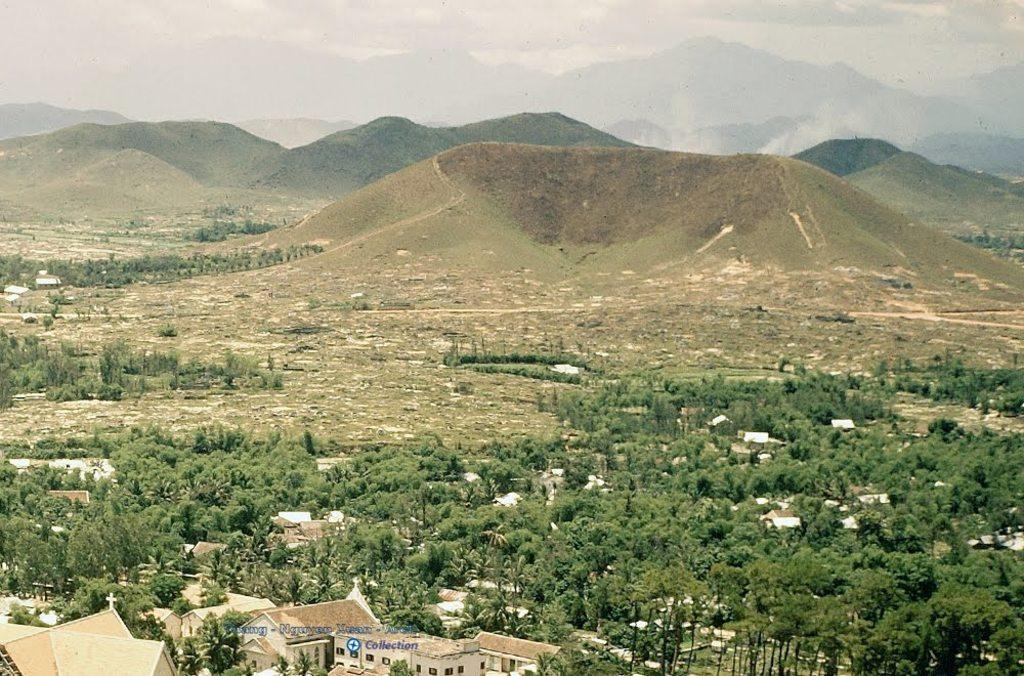What type of natural landscape is in the foreground of the image? There are mountains in the foreground of the image. What type of man-made structure is visible in the foreground of the image? There is a city visible in the foreground of the image. What type of vegetation is present in the foreground of the image? There are trees in the foreground of the image. What part of the natural environment is visible in the foreground of the image? The sky is visible in the foreground of the image. What type of weather condition can be inferred from the image? The presence of a cloud visible in the foreground of the image suggests that there might be some clouds in the sky. Where is the library located in the image? There is no library present in the image. What shape is the beam visible in the image? There is no beam present in the image. 